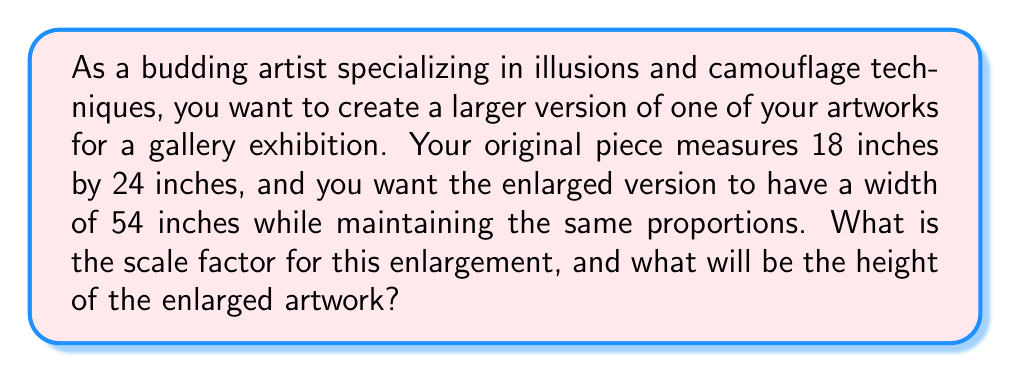Show me your answer to this math problem. To solve this problem, we need to follow these steps:

1. Determine the scale factor:
   The scale factor is the ratio of the new dimension to the original dimension.
   We know the original width is 24 inches and the new width is 54 inches.

   Scale factor = $\frac{\text{New width}}{\text{Original width}} = \frac{54}{24} = \frac{9}{4} = 2.25$

2. Calculate the new height:
   To maintain proportions, we multiply the original height by the same scale factor.
   Original height = 18 inches

   New height = Original height $\times$ Scale factor
   $$\text{New height} = 18 \times \frac{9}{4} = \frac{162}{4} = 40.5 \text{ inches}$$

We can verify that the proportions are maintained:
Original ratio: $\frac{18}{24} = 0.75$
New ratio: $\frac{40.5}{54} = 0.75$

[asy]
size(200);
draw((0,0)--(24,0)--(24,18)--(0,18)--cycle);
draw((30,0)--(84,0)--(84,40.5)--(30,40.5)--cycle);
label("Original", (12,9));
label("Enlarged", (57,20.25));
label("18", (-2,9), W);
label("24", (12,-2), S);
label("40.5", (28,20.25), W);
label("54", (57,-2), S);
[/asy]
Answer: The scale factor for the enlargement is 2.25, and the height of the enlarged artwork will be 40.5 inches. 